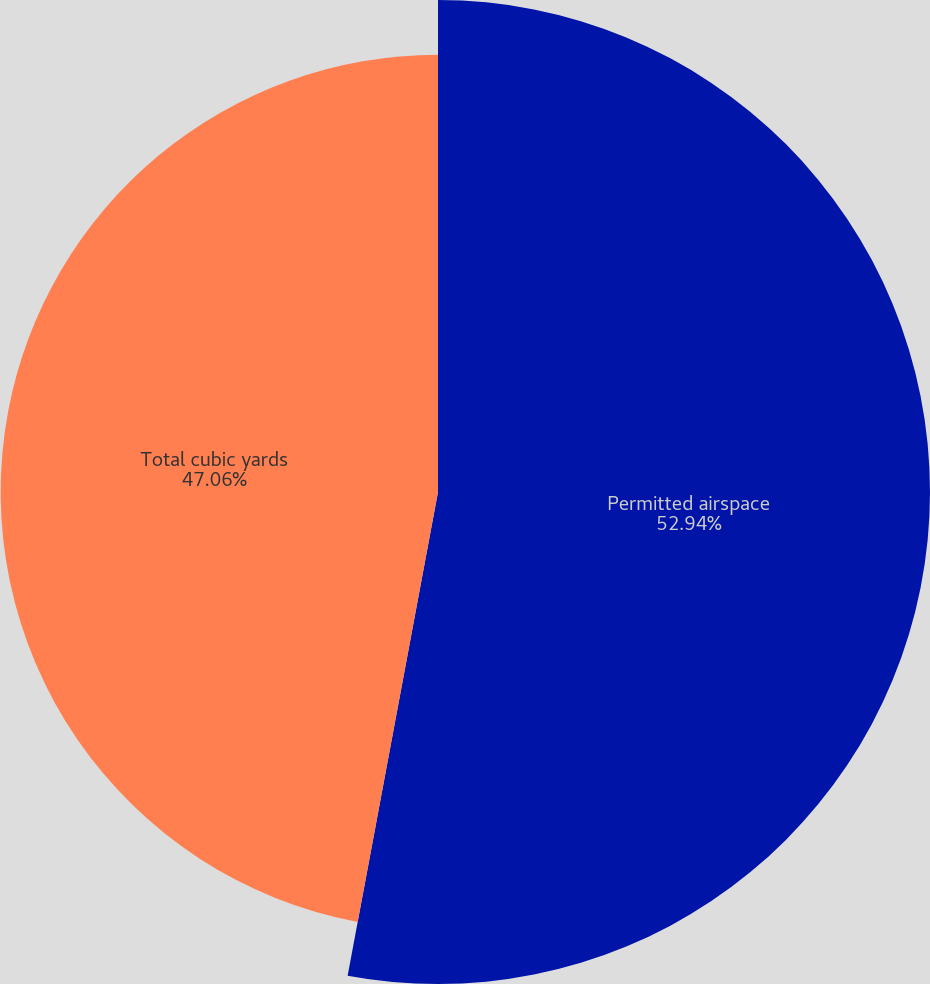<chart> <loc_0><loc_0><loc_500><loc_500><pie_chart><fcel>Permitted airspace<fcel>Total cubic yards<nl><fcel>52.94%<fcel>47.06%<nl></chart> 